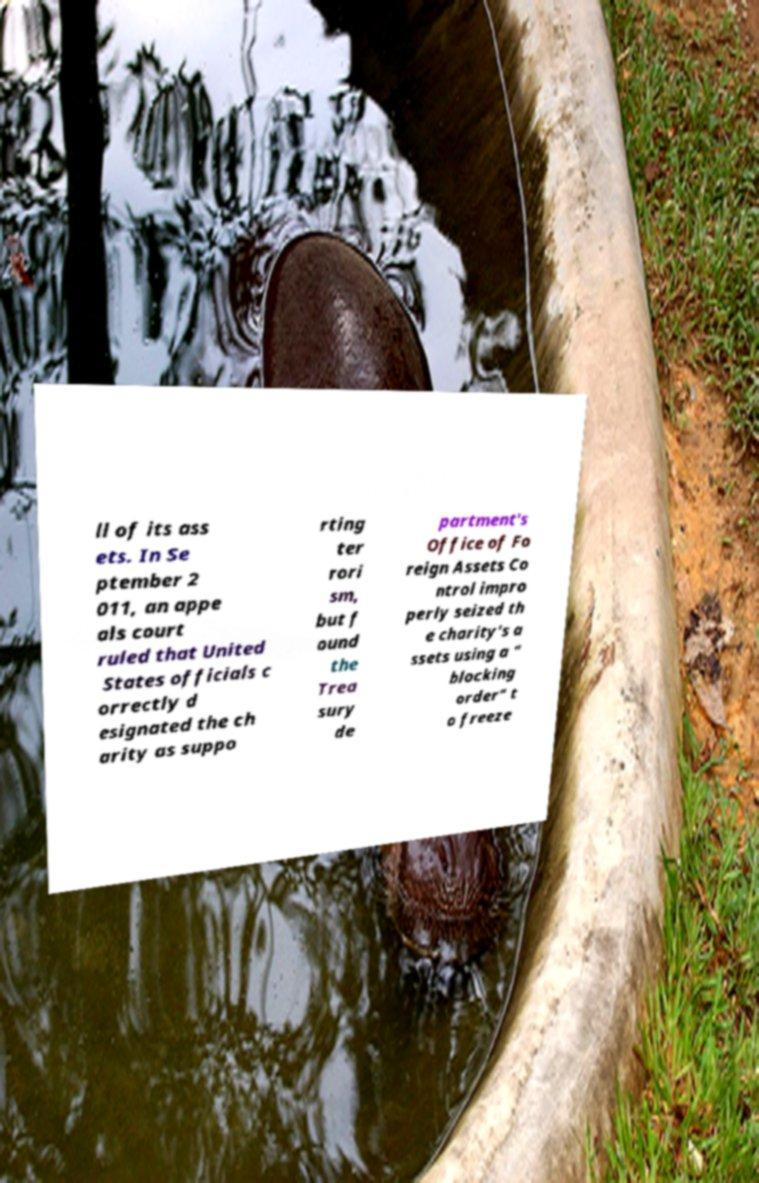For documentation purposes, I need the text within this image transcribed. Could you provide that? ll of its ass ets. In Se ptember 2 011, an appe als court ruled that United States officials c orrectly d esignated the ch arity as suppo rting ter rori sm, but f ound the Trea sury de partment's Office of Fo reign Assets Co ntrol impro perly seized th e charity's a ssets using a " blocking order" t o freeze 